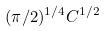Convert formula to latex. <formula><loc_0><loc_0><loc_500><loc_500>( \pi / 2 ) ^ { 1 / 4 } C ^ { 1 / 2 }</formula> 